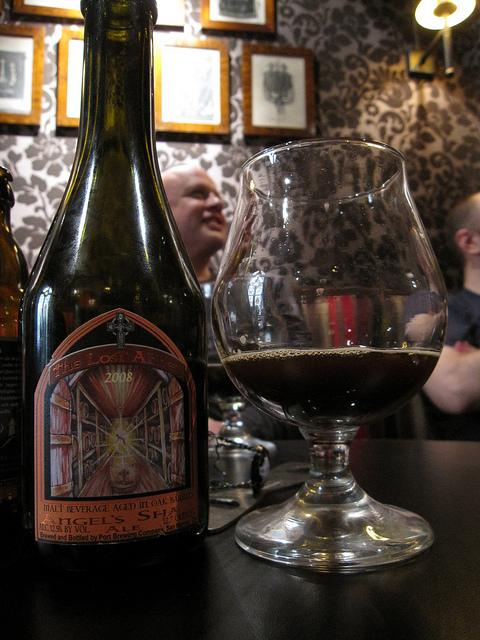What is in the glass? Please explain your reasoning. beer. The low shape of the bottle and of the glass plus the color of the drink seem to indicate that this is an ale. 